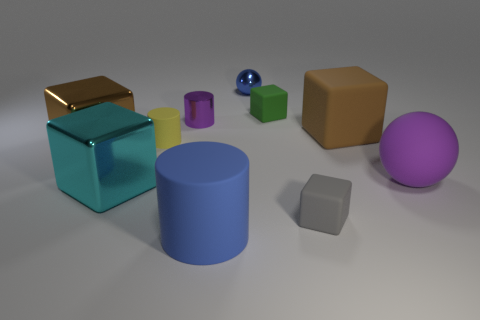Subtract all tiny green rubber cubes. How many cubes are left? 4 Subtract 3 cubes. How many cubes are left? 2 Subtract all cyan blocks. How many blocks are left? 4 Subtract 1 yellow cylinders. How many objects are left? 9 Subtract all balls. How many objects are left? 8 Subtract all green balls. Subtract all cyan cylinders. How many balls are left? 2 Subtract all green cubes. How many cyan cylinders are left? 0 Subtract all tiny blue objects. Subtract all green rubber things. How many objects are left? 8 Add 5 purple spheres. How many purple spheres are left? 6 Add 1 tiny green metal cylinders. How many tiny green metal cylinders exist? 1 